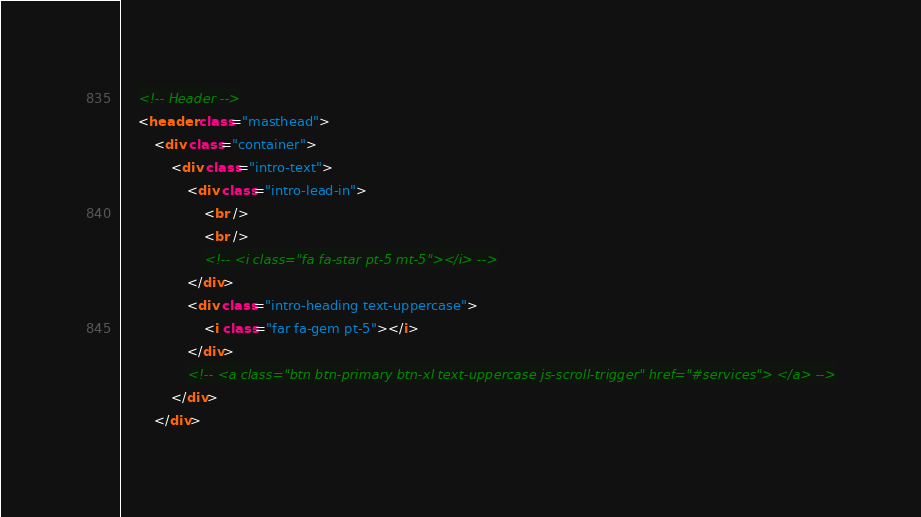<code> <loc_0><loc_0><loc_500><loc_500><_HTML_>    <!-- Header -->
    <header class="masthead">
        <div class="container">
            <div class="intro-text">
                <div class="intro-lead-in">
                    <br />
                    <br />
                    <!-- <i class="fa fa-star pt-5 mt-5"></i> -->
                </div>
                <div class="intro-heading text-uppercase">
                    <i class="far fa-gem pt-5"></i>
                </div>
                <!-- <a class="btn btn-primary btn-xl text-uppercase js-scroll-trigger" href="#services"> </a> -->
            </div>
        </div></code> 